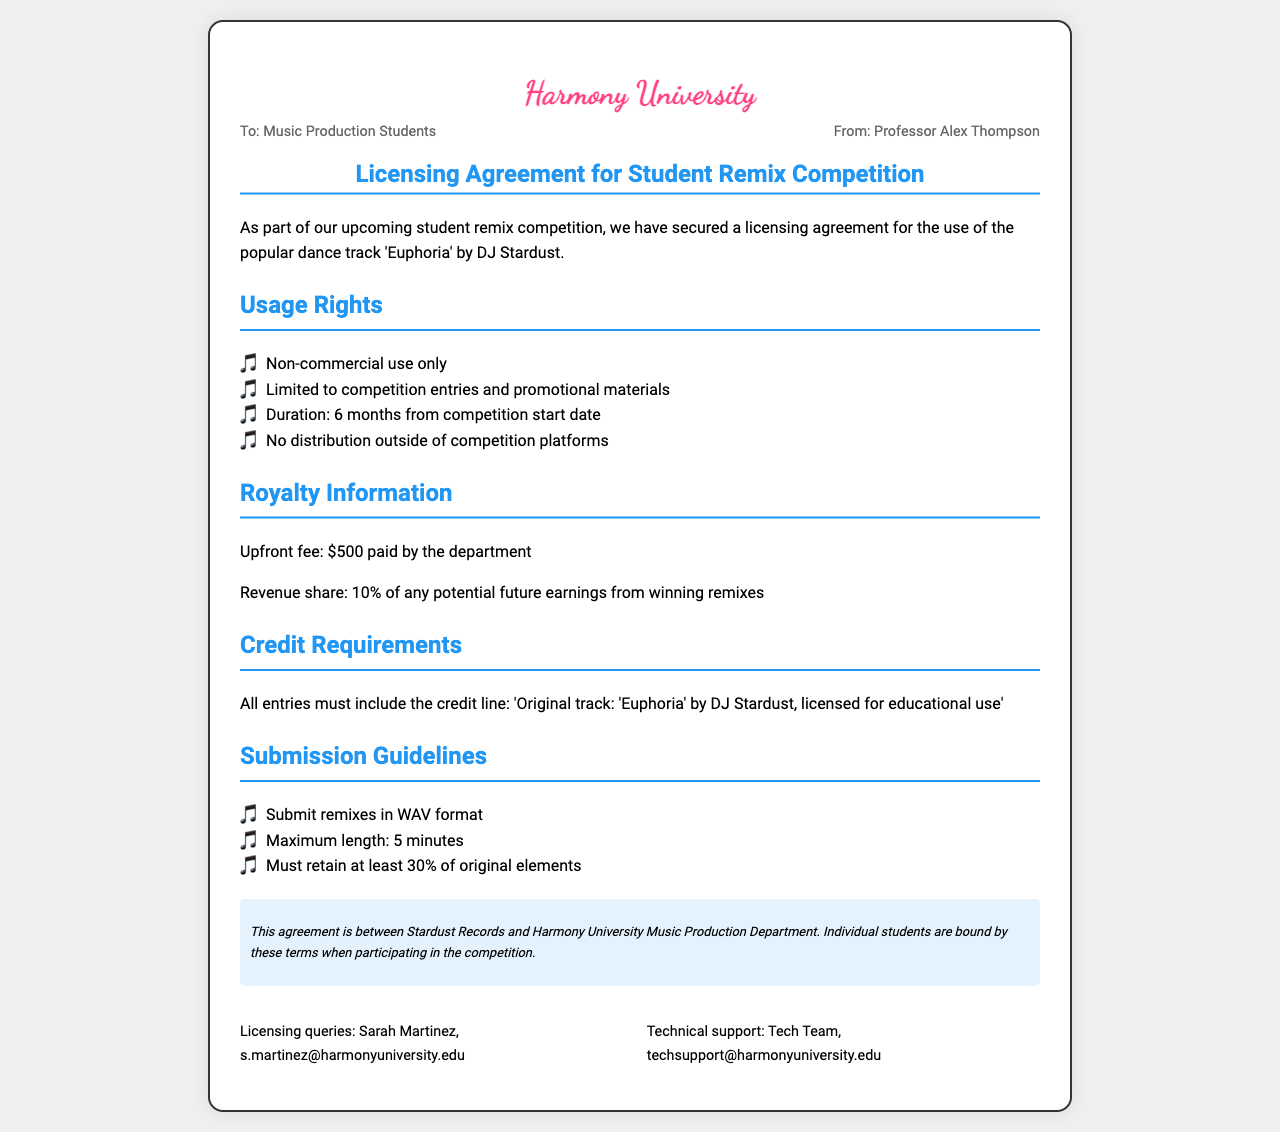What is the title of the dance track? The title of the dance track is mentioned in the agreement and is 'Euphoria'.
Answer: 'Euphoria' Who is the artist of the track? The artist of the track is specified in the document, listed as DJ Stardust.
Answer: DJ Stardust What is the upfront fee for the licensing? The upfront fee is stated clearly in the document as $500.
Answer: $500 How long is the licensing agreement valid for? The duration for which the licensing agreement is valid is specified as 6 months from the competition start date.
Answer: 6 months What percentage of revenue share is outlined for winning remixes? The revenue share percentage given for winning remixes is indicated as 10%.
Answer: 10% What must all entries include as a credit line? The credit line required for all entries is clearly stated in the agreement.
Answer: 'Original track: 'Euphoria' by DJ Stardust, licensed for educational use' What format should remixes be submitted in? The required format for remix submissions is specifically mentioned in the guidelines.
Answer: WAV format What is the maximum length of remixes allowed? The document specifies a maximum length for remixes that is clearly indicated.
Answer: 5 minutes Who can be contacted for licensing queries? The document lists a specific contact person for licensing queries.
Answer: Sarah Martinez 